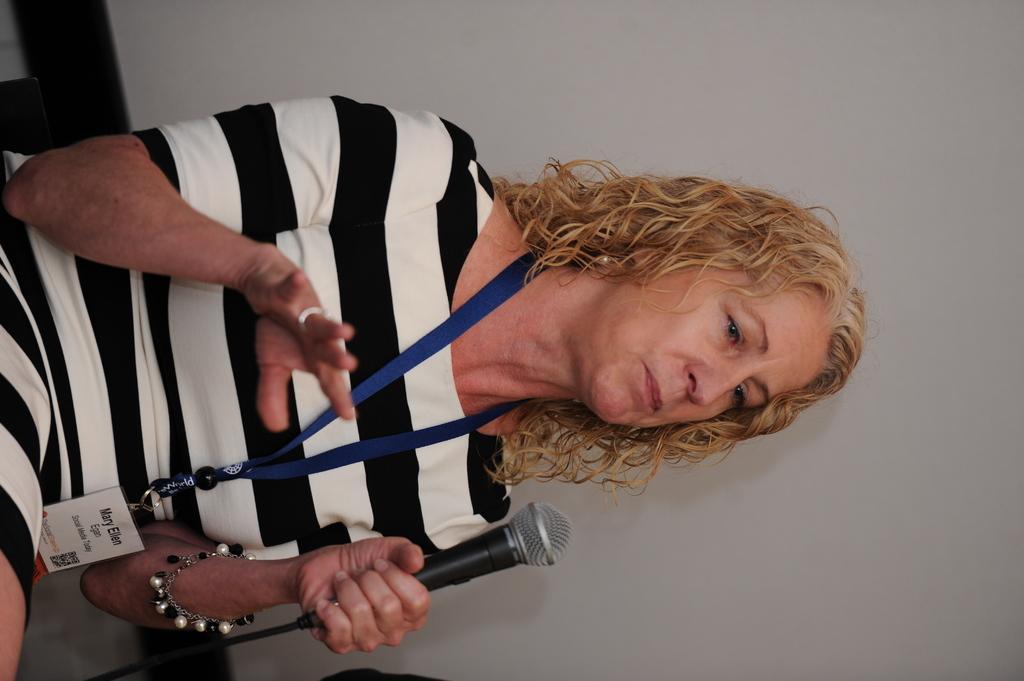How would you summarize this image in a sentence or two? In this image i can see a woman wearing a white and black striped dress and a id card is sitting and holding a microphone in her hand. In the background i can see the wall. 